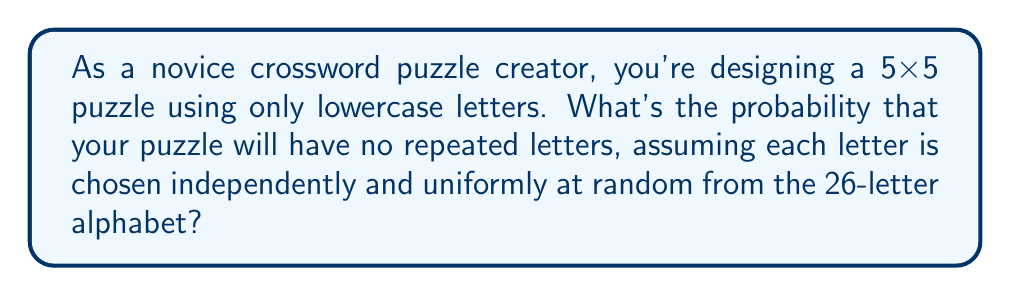Teach me how to tackle this problem. Let's approach this step-by-step:

1) First, we need to understand that a 5x5 puzzle contains 25 squares.

2) To have no repeated letters, we need to select 25 different letters from the 26 available.

3) This is a problem of permutation without repetition. The probability is calculated as follows:

   $$P(\text{no repeats}) = \frac{\text{favorable outcomes}}{\text{total outcomes}}$$

4) Favorable outcomes:
   - For the first letter, we have 26 choices
   - For the second, 25 choices
   - For the third, 24 choices
   ...and so on until the 25th letter, where we have 2 choices

   This can be written as: $26 \cdot 25 \cdot 24 \cdot ... \cdot 3 \cdot 2 = \frac{26!}{1!} = 26!$

5) Total outcomes:
   - For each of the 25 squares, we have 26 choices
   
   This can be written as: $26^{25}$

6) Therefore, the probability is:

   $$P(\text{no repeats}) = \frac{26!}{26^{25}}$$

7) We can simplify this slightly:

   $$P(\text{no repeats}) = \frac{26 \cdot 25 \cdot 24 \cdot ... \cdot 2 \cdot 1}{26 \cdot 26 \cdot ... \cdot 26} = \frac{25!}{26^{24}}$$

8) This probability is extremely small, approximately $1.2 \times 10^{-6}$ or 0.00012%.
Answer: $\frac{25!}{26^{24}}$ 